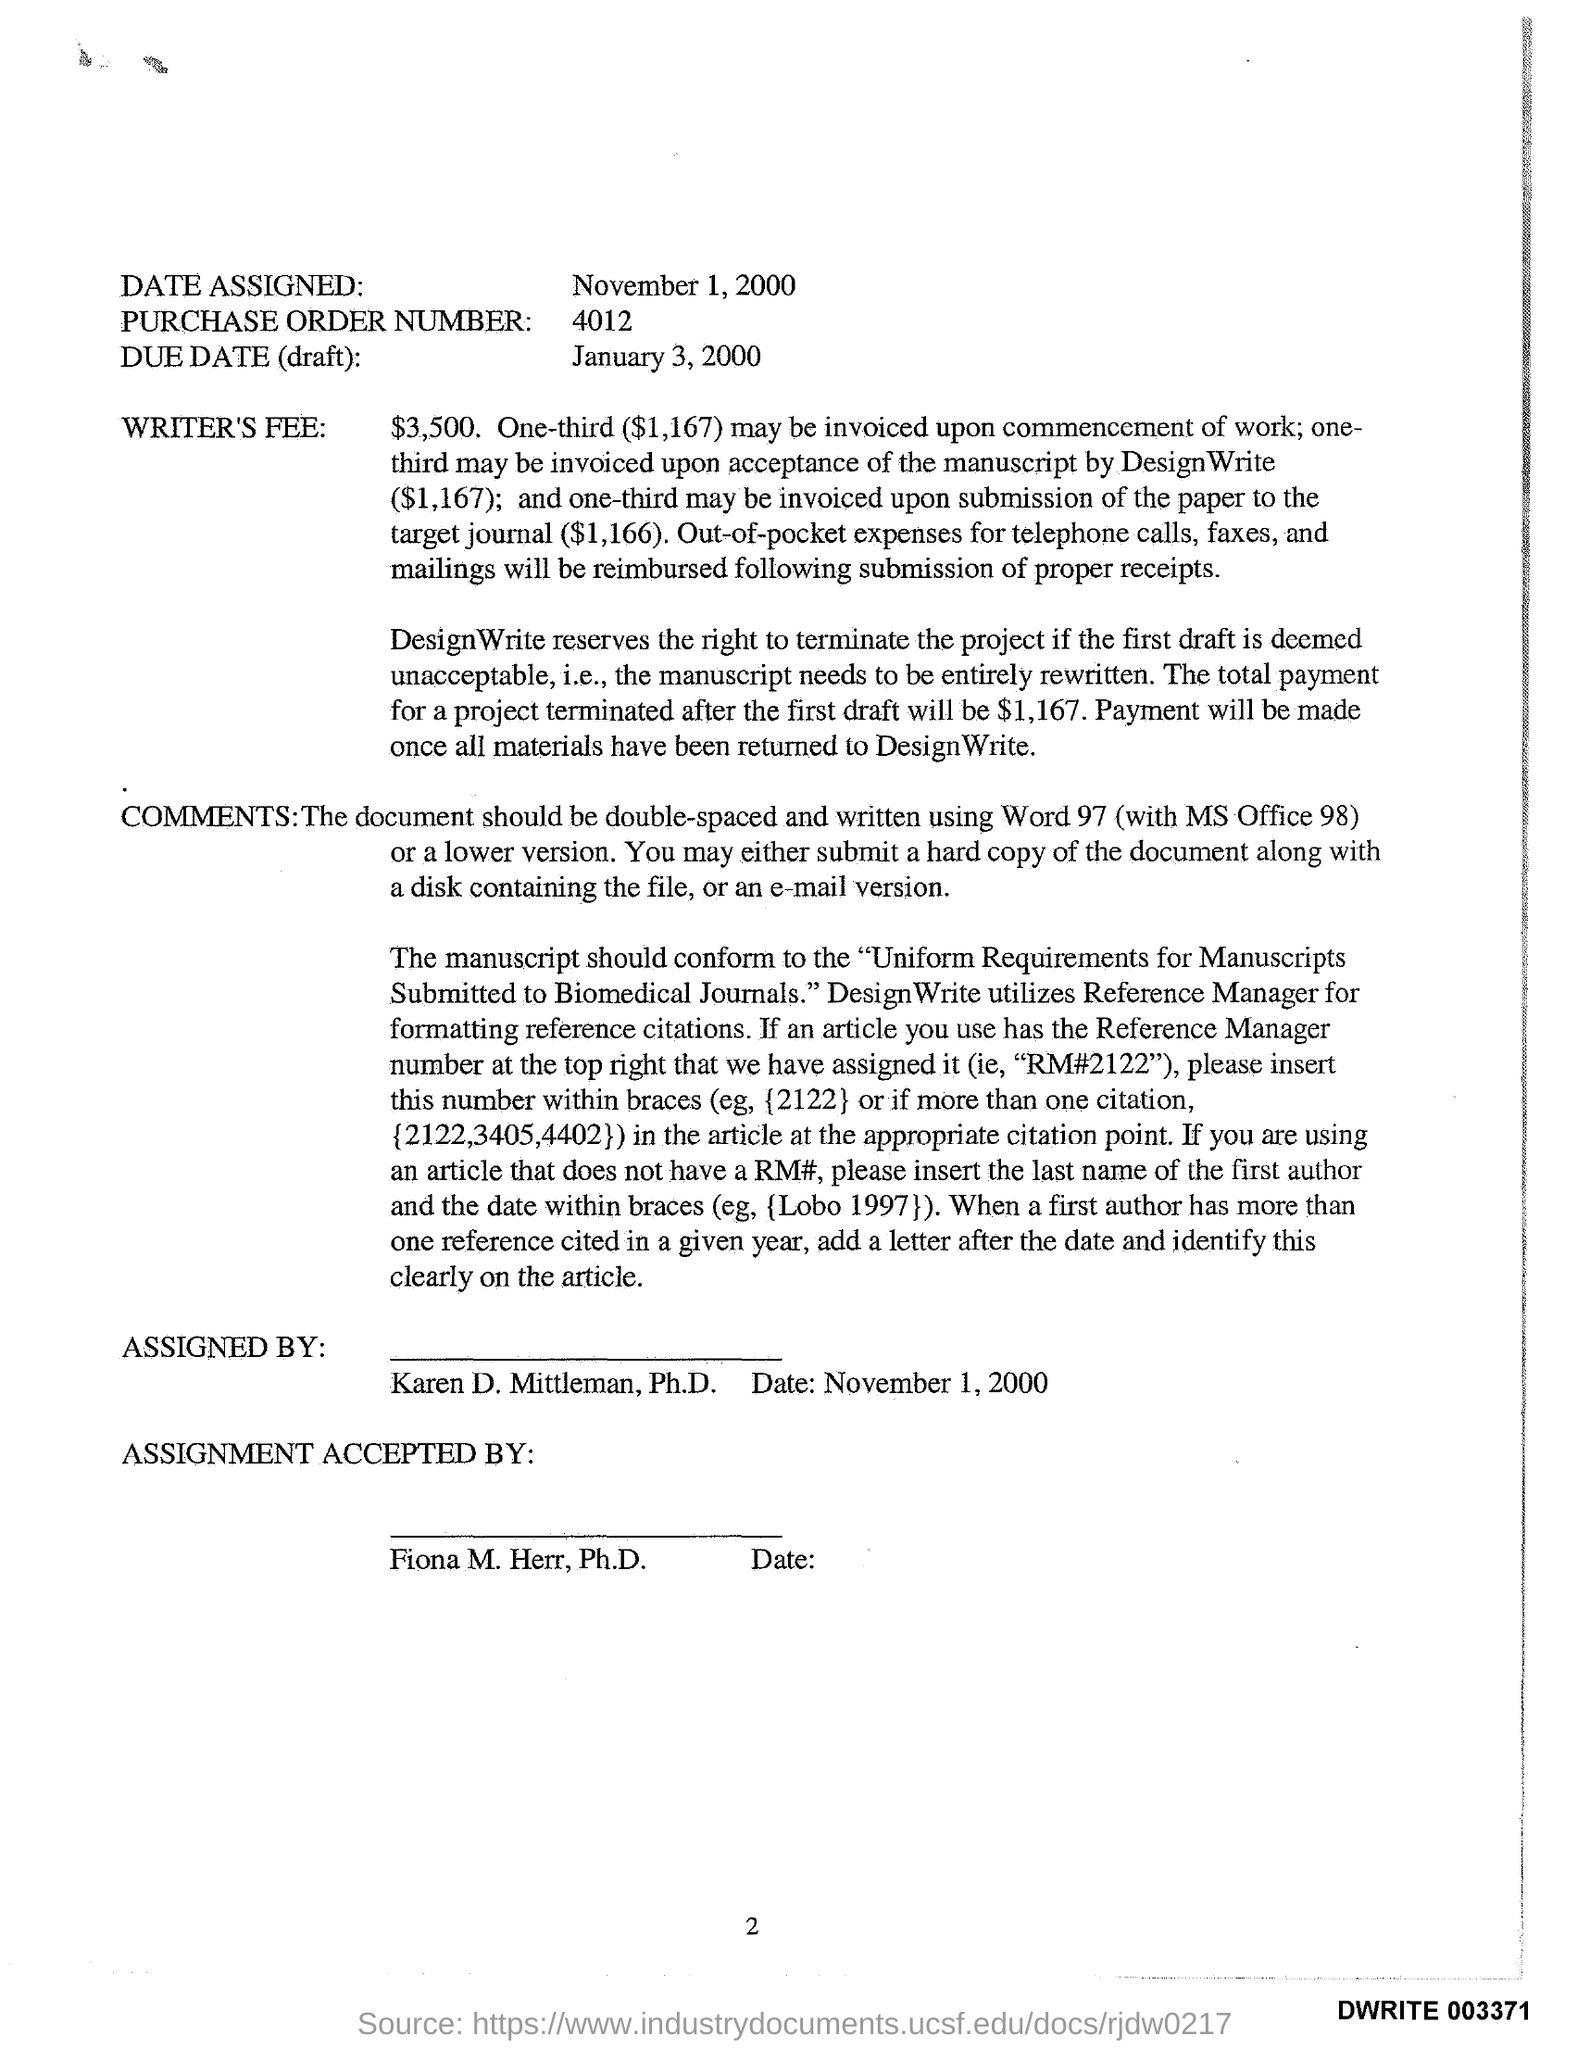Identify some key points in this picture. The writer's fee is $3,500. I'm sorry, but I'm not sure what you are asking for. Could you please provide more context or clarify your question? The date assigned is November 1, 2000. The person who is assigned to this task is Karen D. Mittleman, Ph.D. 